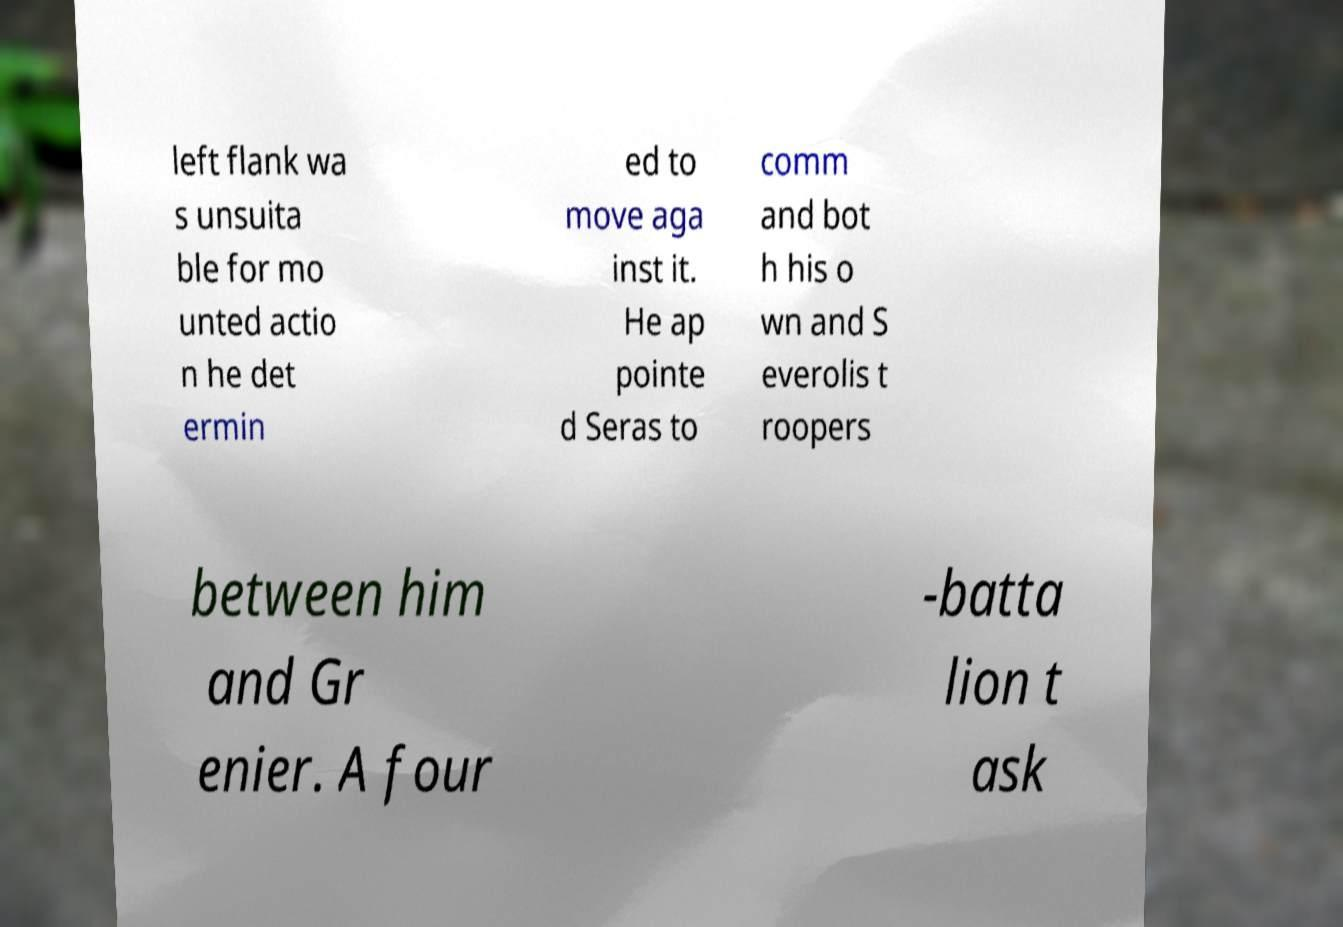I need the written content from this picture converted into text. Can you do that? left flank wa s unsuita ble for mo unted actio n he det ermin ed to move aga inst it. He ap pointe d Seras to comm and bot h his o wn and S everolis t roopers between him and Gr enier. A four -batta lion t ask 